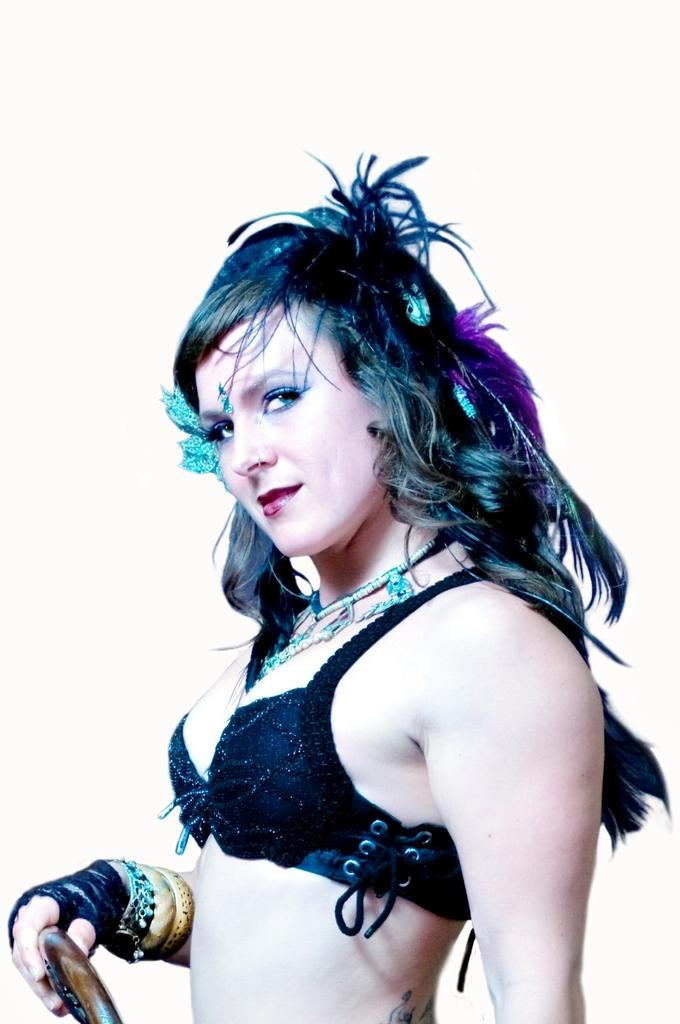What is the woman in the image wearing? The woman is wearing a black dress. What is the woman's facial expression in the image? The woman is smiling. What is the woman holding in the image? The woman is holding an object with one hand. What is the woman's posture in the image? The woman is standing. What is the color of the background in the image? The background of the image is white in color. What type of shoe is the woman wearing in the image? The image does not show the woman's shoes, so it is not possible to determine what type of shoe she is wearing. What flavor of can is the woman holding in the image? There is no can present in the image, so it is not possible to determine the flavor of any can. 